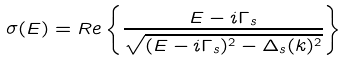<formula> <loc_0><loc_0><loc_500><loc_500>\sigma ( E ) = R e \left \{ \frac { E - i \Gamma _ { s } } { \sqrt { ( E - i \Gamma _ { s } ) ^ { 2 } - \Delta _ { s } ( k ) ^ { 2 } } } \right \}</formula> 